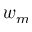Convert formula to latex. <formula><loc_0><loc_0><loc_500><loc_500>w _ { m }</formula> 